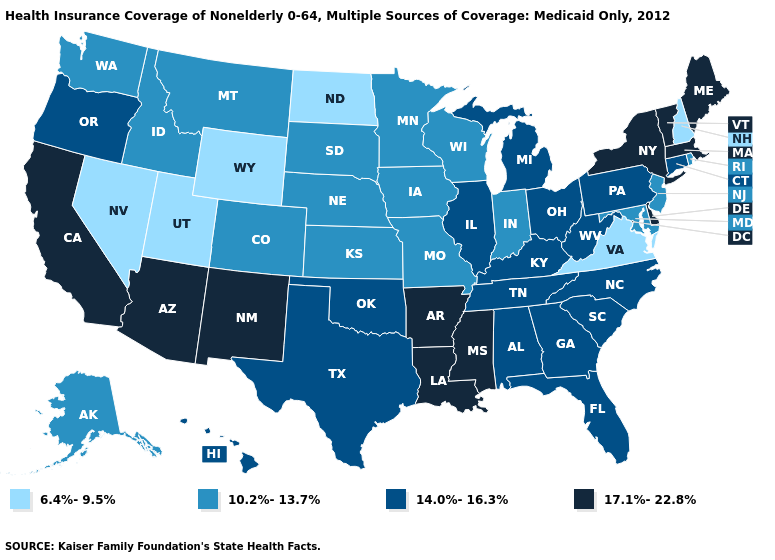Which states have the lowest value in the West?
Be succinct. Nevada, Utah, Wyoming. Name the states that have a value in the range 17.1%-22.8%?
Give a very brief answer. Arizona, Arkansas, California, Delaware, Louisiana, Maine, Massachusetts, Mississippi, New Mexico, New York, Vermont. Name the states that have a value in the range 17.1%-22.8%?
Be succinct. Arizona, Arkansas, California, Delaware, Louisiana, Maine, Massachusetts, Mississippi, New Mexico, New York, Vermont. Among the states that border Colorado , which have the lowest value?
Give a very brief answer. Utah, Wyoming. Name the states that have a value in the range 17.1%-22.8%?
Answer briefly. Arizona, Arkansas, California, Delaware, Louisiana, Maine, Massachusetts, Mississippi, New Mexico, New York, Vermont. Does the first symbol in the legend represent the smallest category?
Be succinct. Yes. What is the value of Georgia?
Short answer required. 14.0%-16.3%. Does Florida have a lower value than Iowa?
Keep it brief. No. Name the states that have a value in the range 17.1%-22.8%?
Be succinct. Arizona, Arkansas, California, Delaware, Louisiana, Maine, Massachusetts, Mississippi, New Mexico, New York, Vermont. Name the states that have a value in the range 10.2%-13.7%?
Write a very short answer. Alaska, Colorado, Idaho, Indiana, Iowa, Kansas, Maryland, Minnesota, Missouri, Montana, Nebraska, New Jersey, Rhode Island, South Dakota, Washington, Wisconsin. What is the value of Mississippi?
Give a very brief answer. 17.1%-22.8%. What is the lowest value in the USA?
Quick response, please. 6.4%-9.5%. Name the states that have a value in the range 14.0%-16.3%?
Answer briefly. Alabama, Connecticut, Florida, Georgia, Hawaii, Illinois, Kentucky, Michigan, North Carolina, Ohio, Oklahoma, Oregon, Pennsylvania, South Carolina, Tennessee, Texas, West Virginia. Does California have the highest value in the USA?
Be succinct. Yes. Which states hav the highest value in the South?
Concise answer only. Arkansas, Delaware, Louisiana, Mississippi. 